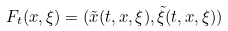<formula> <loc_0><loc_0><loc_500><loc_500>F _ { t } ( x , \xi ) = ( \tilde { x } ( t , x , \xi ) , \tilde { \xi } ( t , x , \xi ) )</formula> 